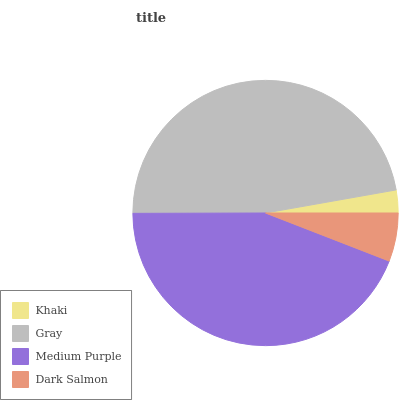Is Khaki the minimum?
Answer yes or no. Yes. Is Gray the maximum?
Answer yes or no. Yes. Is Medium Purple the minimum?
Answer yes or no. No. Is Medium Purple the maximum?
Answer yes or no. No. Is Gray greater than Medium Purple?
Answer yes or no. Yes. Is Medium Purple less than Gray?
Answer yes or no. Yes. Is Medium Purple greater than Gray?
Answer yes or no. No. Is Gray less than Medium Purple?
Answer yes or no. No. Is Medium Purple the high median?
Answer yes or no. Yes. Is Dark Salmon the low median?
Answer yes or no. Yes. Is Khaki the high median?
Answer yes or no. No. Is Medium Purple the low median?
Answer yes or no. No. 